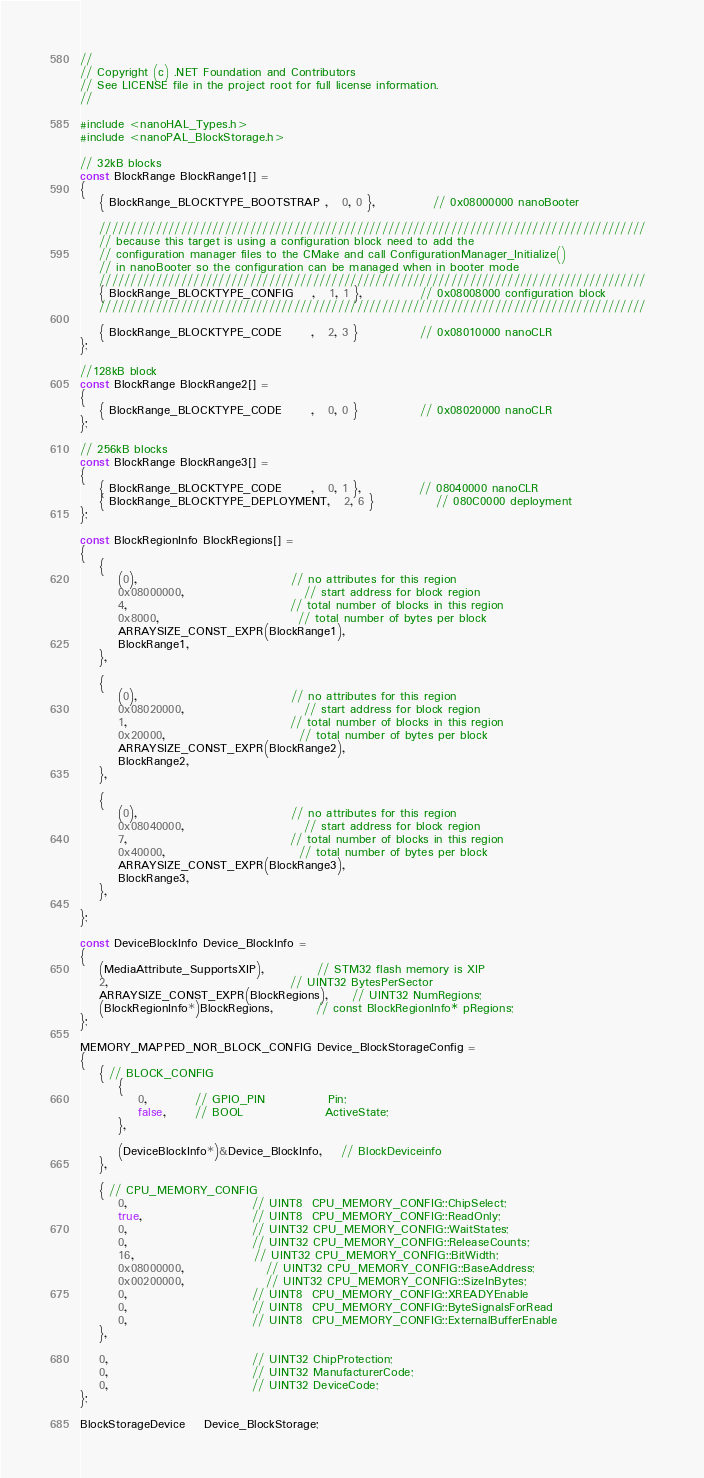Convert code to text. <code><loc_0><loc_0><loc_500><loc_500><_C_>//
// Copyright (c) .NET Foundation and Contributors
// See LICENSE file in the project root for full license information.
//

#include <nanoHAL_Types.h>
#include <nanoPAL_BlockStorage.h>

// 32kB blocks
const BlockRange BlockRange1[] =
{
    { BlockRange_BLOCKTYPE_BOOTSTRAP ,   0, 0 },            // 0x08000000 nanoBooter         

    ///////////////////////////////////////////////////////////////////////////////////////
    // because this target is using a configuration block need to add the
    // configuration manager files to the CMake and call ConfigurationManager_Initialize()
    // in nanoBooter so the configuration can be managed when in booter mode
    ///////////////////////////////////////////////////////////////////////////////////////
    { BlockRange_BLOCKTYPE_CONFIG    ,   1, 1 },            // 0x08008000 configuration block          
    ///////////////////////////////////////////////////////////////////////////////////////

    { BlockRange_BLOCKTYPE_CODE      ,   2, 3 }             // 0x08010000 nanoCLR          
};

//128kB block
const BlockRange BlockRange2[] =
{
    { BlockRange_BLOCKTYPE_CODE      ,   0, 0 }             // 0x08020000 nanoCLR          
};

// 256kB blocks
const BlockRange BlockRange3[] =
{
    { BlockRange_BLOCKTYPE_CODE      ,   0, 1 },            // 08040000 nanoCLR  
    { BlockRange_BLOCKTYPE_DEPLOYMENT,   2, 6 }             // 080C0000 deployment  
};

const BlockRegionInfo BlockRegions[] = 
{
    {
        (0),                                // no attributes for this region
        0x08000000,                         // start address for block region
        4,                                  // total number of blocks in this region
        0x8000,                             // total number of bytes per block
        ARRAYSIZE_CONST_EXPR(BlockRange1),
        BlockRange1,
    },

    {
        (0),                                // no attributes for this region
        0x08020000,                         // start address for block region
        1,                                  // total number of blocks in this region
        0x20000,                            // total number of bytes per block
        ARRAYSIZE_CONST_EXPR(BlockRange2),
        BlockRange2,
    },

    {
        (0),                                // no attributes for this region
        0x08040000,                         // start address for block region
        7,                                  // total number of blocks in this region
        0x40000,                            // total number of bytes per block
        ARRAYSIZE_CONST_EXPR(BlockRange3),
        BlockRange3,
    },

};

const DeviceBlockInfo Device_BlockInfo =
{
    (MediaAttribute_SupportsXIP),           // STM32 flash memory is XIP
    2,                                      // UINT32 BytesPerSector
    ARRAYSIZE_CONST_EXPR(BlockRegions),     // UINT32 NumRegions;
    (BlockRegionInfo*)BlockRegions,         // const BlockRegionInfo* pRegions;
};

MEMORY_MAPPED_NOR_BLOCK_CONFIG Device_BlockStorageConfig =
{
    { // BLOCK_CONFIG
        {
            0,          // GPIO_PIN             Pin;
            false,      // BOOL                 ActiveState;
        },

        (DeviceBlockInfo*)&Device_BlockInfo,    // BlockDeviceinfo
    },

    { // CPU_MEMORY_CONFIG
        0,                          // UINT8  CPU_MEMORY_CONFIG::ChipSelect;
        true,                       // UINT8  CPU_MEMORY_CONFIG::ReadOnly;
        0,                          // UINT32 CPU_MEMORY_CONFIG::WaitStates;
        0,                          // UINT32 CPU_MEMORY_CONFIG::ReleaseCounts;
        16,                         // UINT32 CPU_MEMORY_CONFIG::BitWidth;
        0x08000000,                 // UINT32 CPU_MEMORY_CONFIG::BaseAddress;
        0x00200000,                 // UINT32 CPU_MEMORY_CONFIG::SizeInBytes;
        0,                          // UINT8  CPU_MEMORY_CONFIG::XREADYEnable 
        0,                          // UINT8  CPU_MEMORY_CONFIG::ByteSignalsForRead 
        0,                          // UINT8  CPU_MEMORY_CONFIG::ExternalBufferEnable
    },

    0,                              // UINT32 ChipProtection;
    0,                              // UINT32 ManufacturerCode;
    0,                              // UINT32 DeviceCode;
};

BlockStorageDevice    Device_BlockStorage;
</code> 